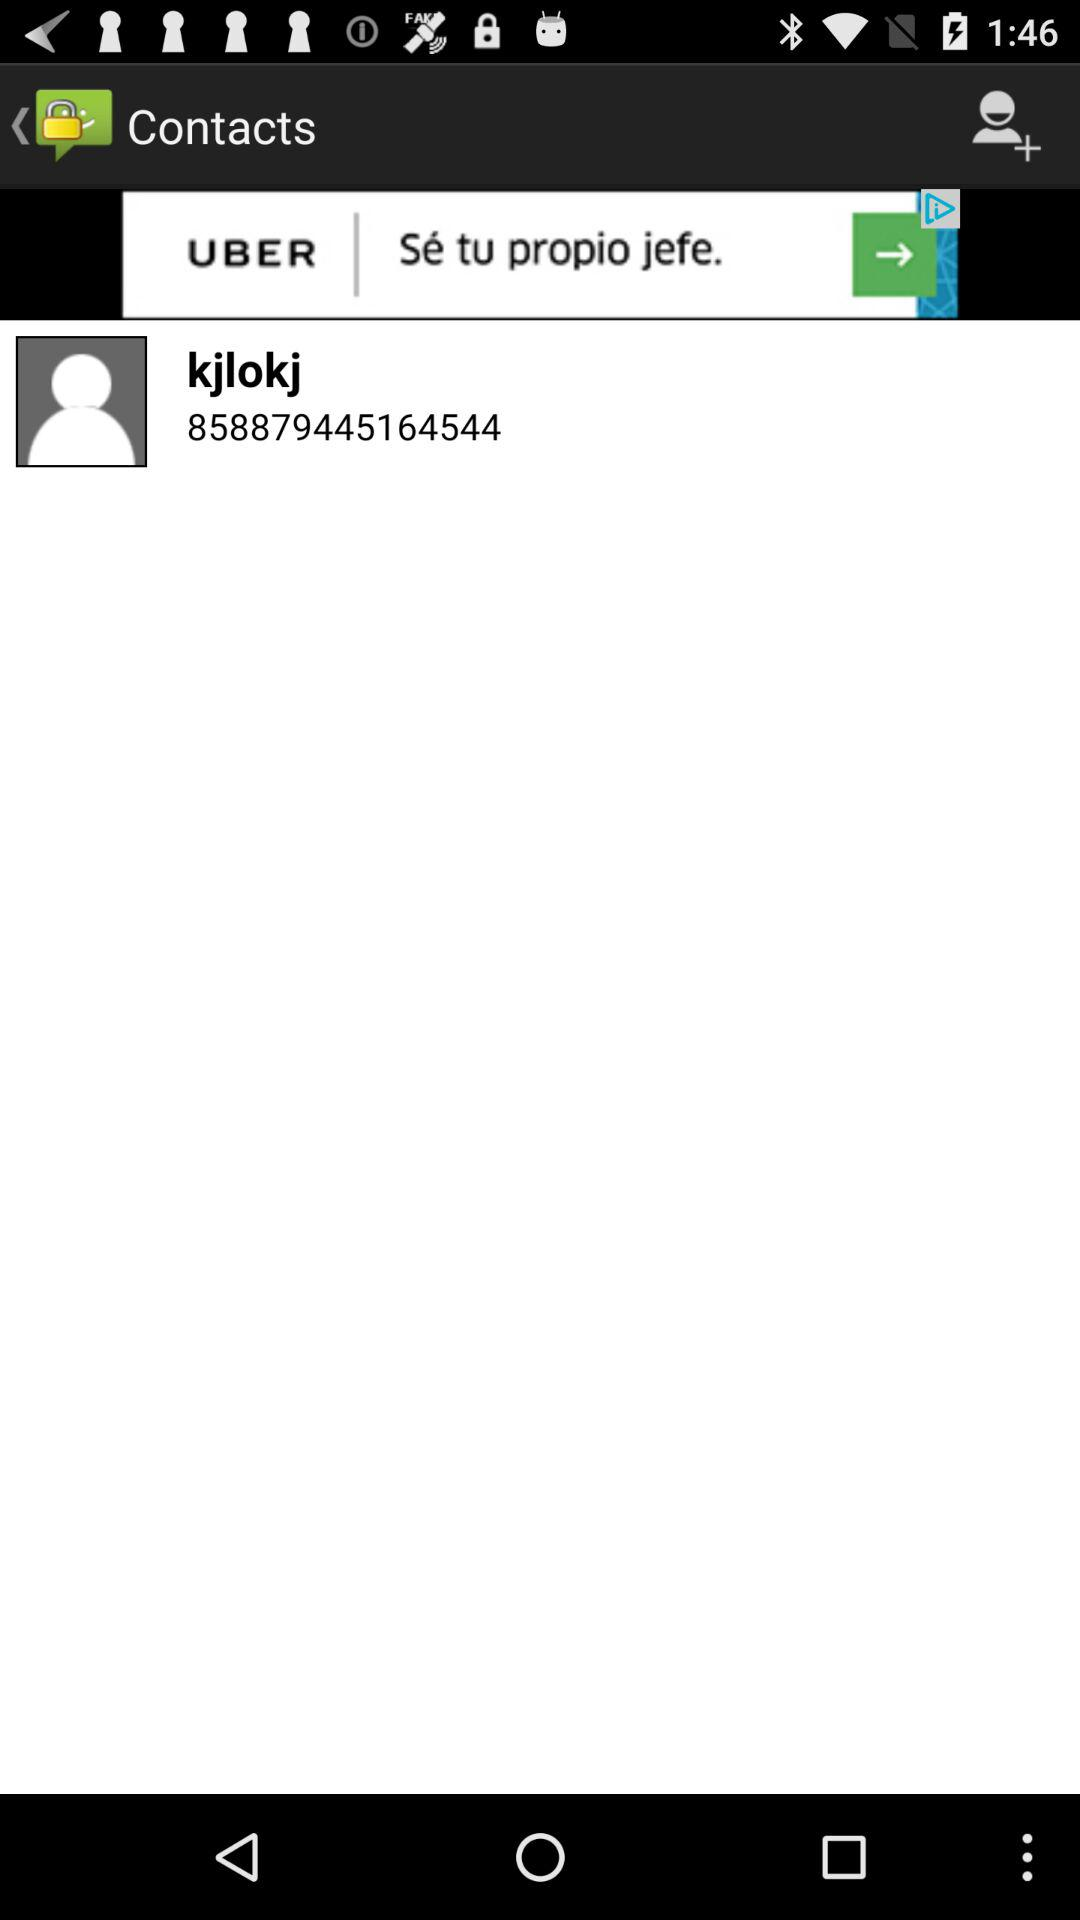What's the contact name? The contact number is 858879445164544. 